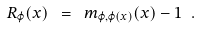Convert formula to latex. <formula><loc_0><loc_0><loc_500><loc_500>R _ { \varphi } ( x ) \ = \ m _ { \varphi , \varphi ( x ) } ( x ) - 1 \ .</formula> 